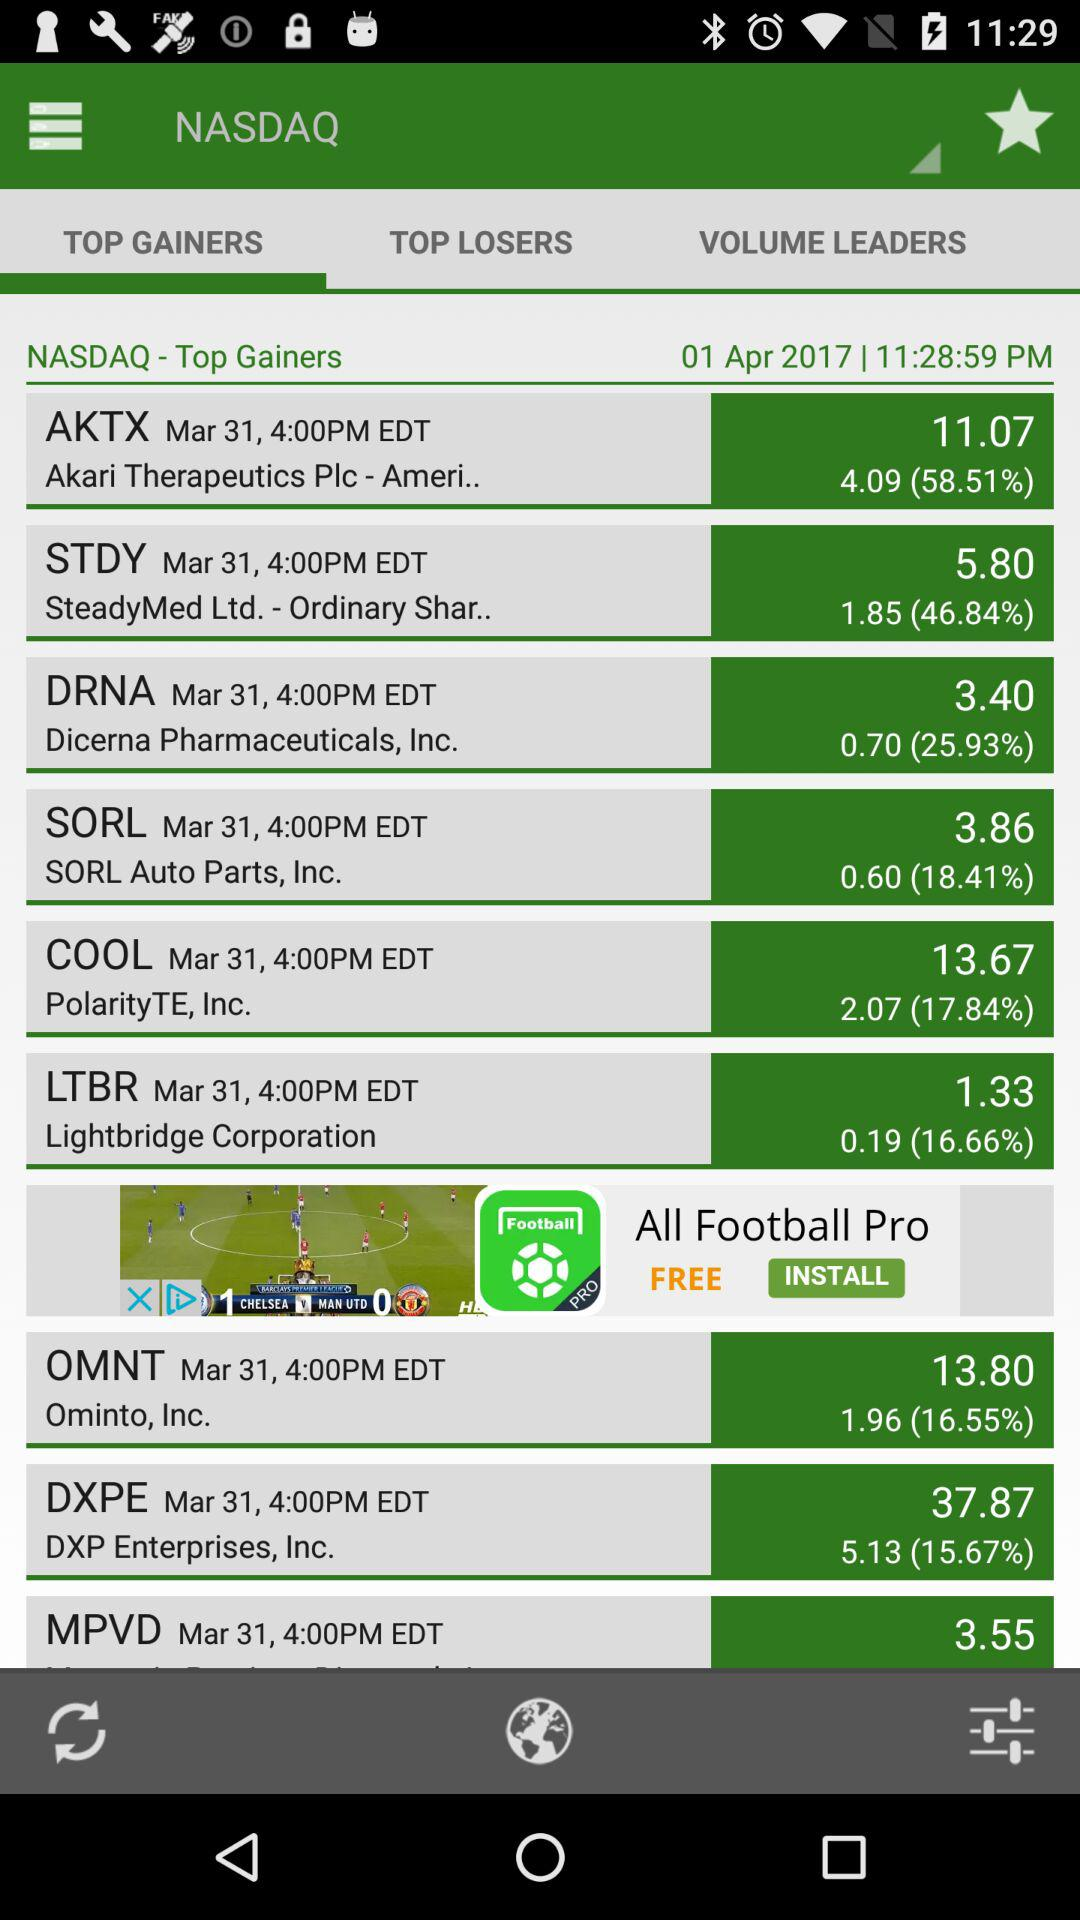What is the increased % of COOL in "TOP GAINERS"? The increased % of COOL is 17.84. 